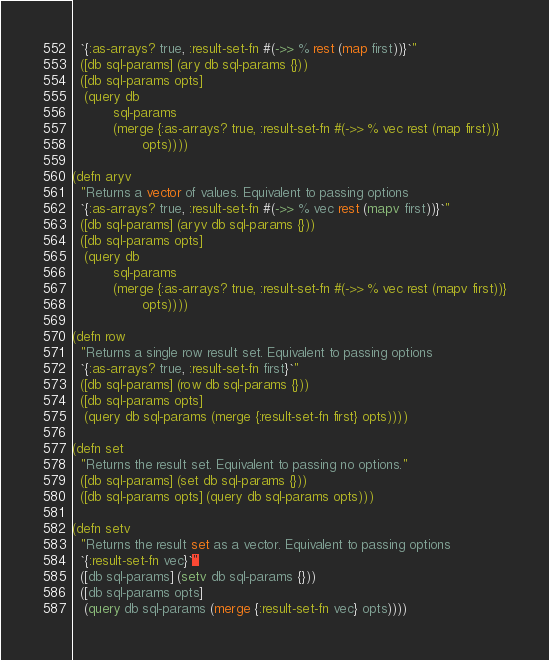<code> <loc_0><loc_0><loc_500><loc_500><_Clojure_>  `{:as-arrays? true, :result-set-fn #(->> % rest (map first))}`"
  ([db sql-params] (ary db sql-params {}))
  ([db sql-params opts]
   (query db
          sql-params
          (merge {:as-arrays? true, :result-set-fn #(->> % vec rest (map first))}
                 opts))))

(defn aryv
  "Returns a vector of values. Equivalent to passing options
  `{:as-arrays? true, :result-set-fn #(->> % vec rest (mapv first))}`"
  ([db sql-params] (aryv db sql-params {}))
  ([db sql-params opts]
   (query db
          sql-params
          (merge {:as-arrays? true, :result-set-fn #(->> % vec rest (mapv first))}
                 opts))))

(defn row
  "Returns a single row result set. Equivalent to passing options
  `{:as-arrays? true, :result-set-fn first}`"
  ([db sql-params] (row db sql-params {}))
  ([db sql-params opts]
   (query db sql-params (merge {:result-set-fn first} opts))))

(defn set
  "Returns the result set. Equivalent to passing no options."
  ([db sql-params] (set db sql-params {}))
  ([db sql-params opts] (query db sql-params opts)))

(defn setv
  "Returns the result set as a vector. Equivalent to passing options
  `{:result-set-fn vec}`"
  ([db sql-params] (setv db sql-params {}))
  ([db sql-params opts]
   (query db sql-params (merge {:result-set-fn vec} opts))))
</code> 